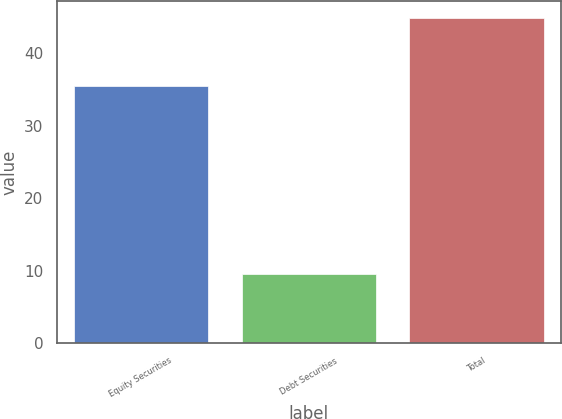Convert chart to OTSL. <chart><loc_0><loc_0><loc_500><loc_500><bar_chart><fcel>Equity Securities<fcel>Debt Securities<fcel>Total<nl><fcel>35.4<fcel>9.5<fcel>44.9<nl></chart> 